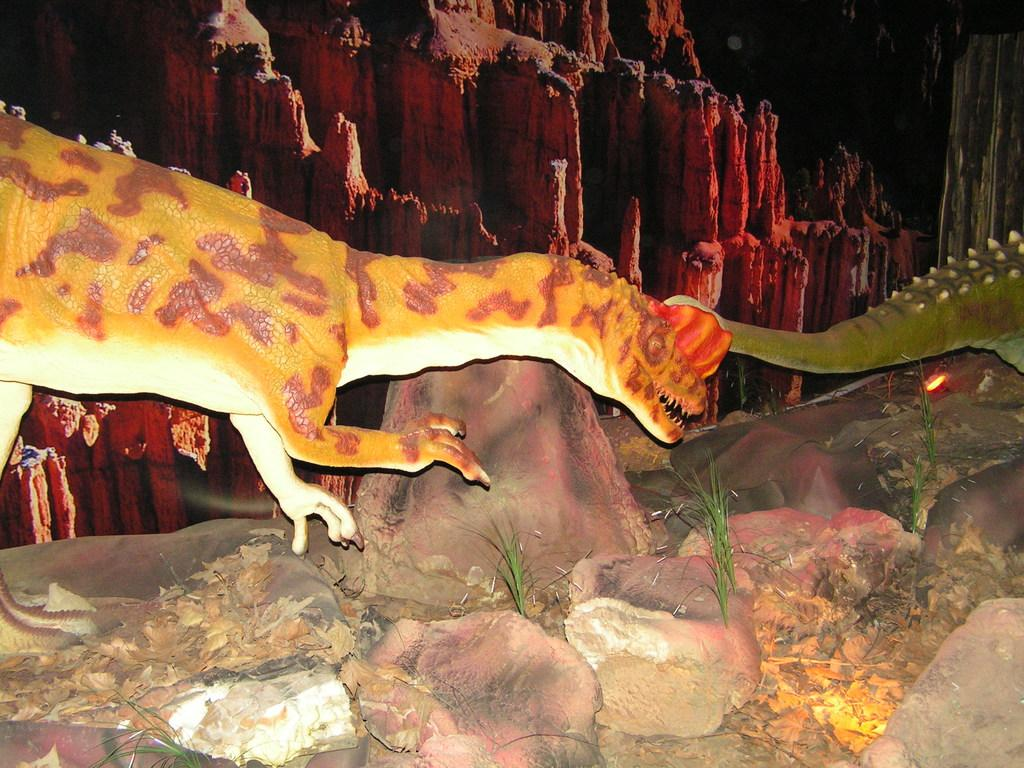What is the main subject of the image? There is a dinosaur in the image. Can you describe the color of the dinosaur? The dinosaur is yellow and maroon in color. What other objects can be seen in the image? There are stones and dried leaves in the image. What is visible in the background of the image? There is a hill in the background of the image. Can you tell me how the dinosaur is pulling the team in the image? There is no team present in the image, and the dinosaur is not pulling anything. 